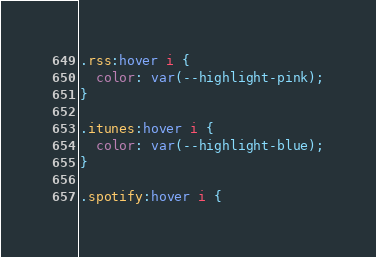Convert code to text. <code><loc_0><loc_0><loc_500><loc_500><_CSS_>
.rss:hover i {
  color: var(--highlight-pink);
}

.itunes:hover i {
  color: var(--highlight-blue);
}

.spotify:hover i {</code> 